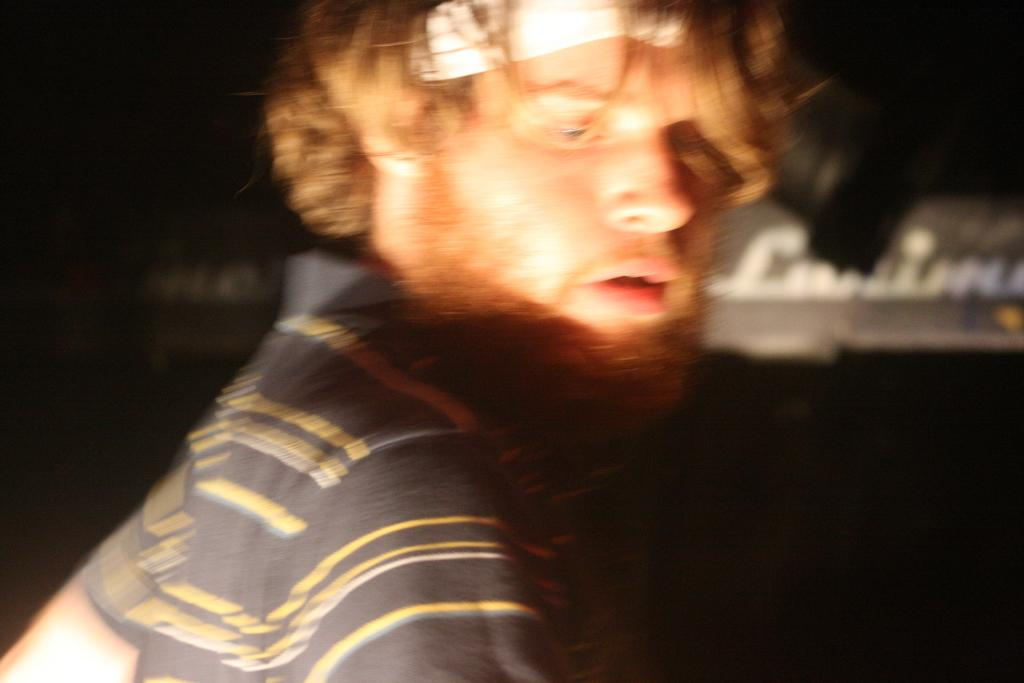Who or what is the main subject in the image? There is a person in the image. What object is located on the right side of the image? There is a text board on the right side of the image. How would you describe the overall lighting or color of the image? The background of the image is dark. What type of silver root can be seen in the image? There is no silver root present in the image. What holiday is being celebrated in the image? The image does not depict a holiday or any celebratory event. 